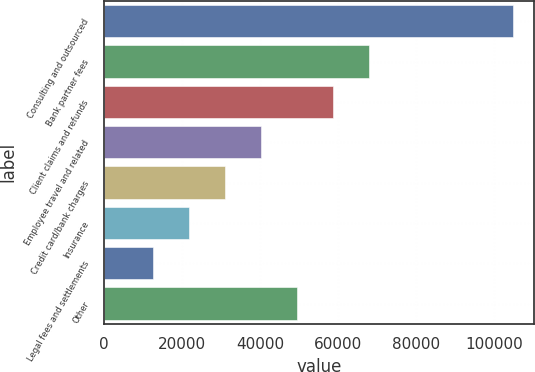Convert chart to OTSL. <chart><loc_0><loc_0><loc_500><loc_500><bar_chart><fcel>Consulting and outsourced<fcel>Bank partner fees<fcel>Client claims and refunds<fcel>Employee travel and related<fcel>Credit card/bank charges<fcel>Insurance<fcel>Legal fees and settlements<fcel>Other<nl><fcel>104995<fcel>68032.6<fcel>58792<fcel>40310.8<fcel>31070.2<fcel>21829.6<fcel>12589<fcel>49551.4<nl></chart> 